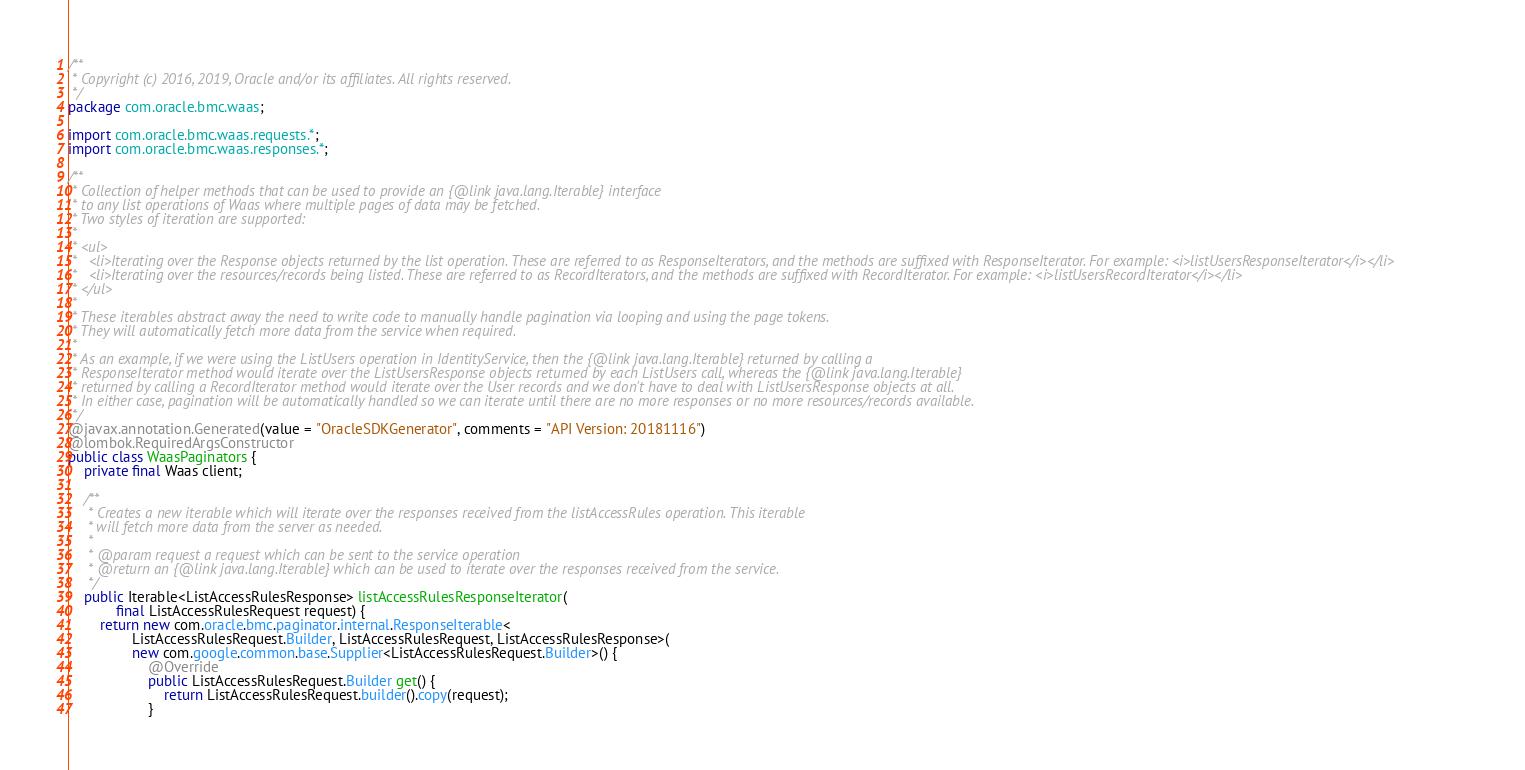Convert code to text. <code><loc_0><loc_0><loc_500><loc_500><_Java_>/**
 * Copyright (c) 2016, 2019, Oracle and/or its affiliates. All rights reserved.
 */
package com.oracle.bmc.waas;

import com.oracle.bmc.waas.requests.*;
import com.oracle.bmc.waas.responses.*;

/**
 * Collection of helper methods that can be used to provide an {@link java.lang.Iterable} interface
 * to any list operations of Waas where multiple pages of data may be fetched.
 * Two styles of iteration are supported:
 *
 * <ul>
 *   <li>Iterating over the Response objects returned by the list operation. These are referred to as ResponseIterators, and the methods are suffixed with ResponseIterator. For example: <i>listUsersResponseIterator</i></li>
 *   <li>Iterating over the resources/records being listed. These are referred to as RecordIterators, and the methods are suffixed with RecordIterator. For example: <i>listUsersRecordIterator</i></li>
 * </ul>
 *
 * These iterables abstract away the need to write code to manually handle pagination via looping and using the page tokens.
 * They will automatically fetch more data from the service when required.
 *
 * As an example, if we were using the ListUsers operation in IdentityService, then the {@link java.lang.Iterable} returned by calling a
 * ResponseIterator method would iterate over the ListUsersResponse objects returned by each ListUsers call, whereas the {@link java.lang.Iterable}
 * returned by calling a RecordIterator method would iterate over the User records and we don't have to deal with ListUsersResponse objects at all.
 * In either case, pagination will be automatically handled so we can iterate until there are no more responses or no more resources/records available.
 */
@javax.annotation.Generated(value = "OracleSDKGenerator", comments = "API Version: 20181116")
@lombok.RequiredArgsConstructor
public class WaasPaginators {
    private final Waas client;

    /**
     * Creates a new iterable which will iterate over the responses received from the listAccessRules operation. This iterable
     * will fetch more data from the server as needed.
     *
     * @param request a request which can be sent to the service operation
     * @return an {@link java.lang.Iterable} which can be used to iterate over the responses received from the service.
     */
    public Iterable<ListAccessRulesResponse> listAccessRulesResponseIterator(
            final ListAccessRulesRequest request) {
        return new com.oracle.bmc.paginator.internal.ResponseIterable<
                ListAccessRulesRequest.Builder, ListAccessRulesRequest, ListAccessRulesResponse>(
                new com.google.common.base.Supplier<ListAccessRulesRequest.Builder>() {
                    @Override
                    public ListAccessRulesRequest.Builder get() {
                        return ListAccessRulesRequest.builder().copy(request);
                    }</code> 